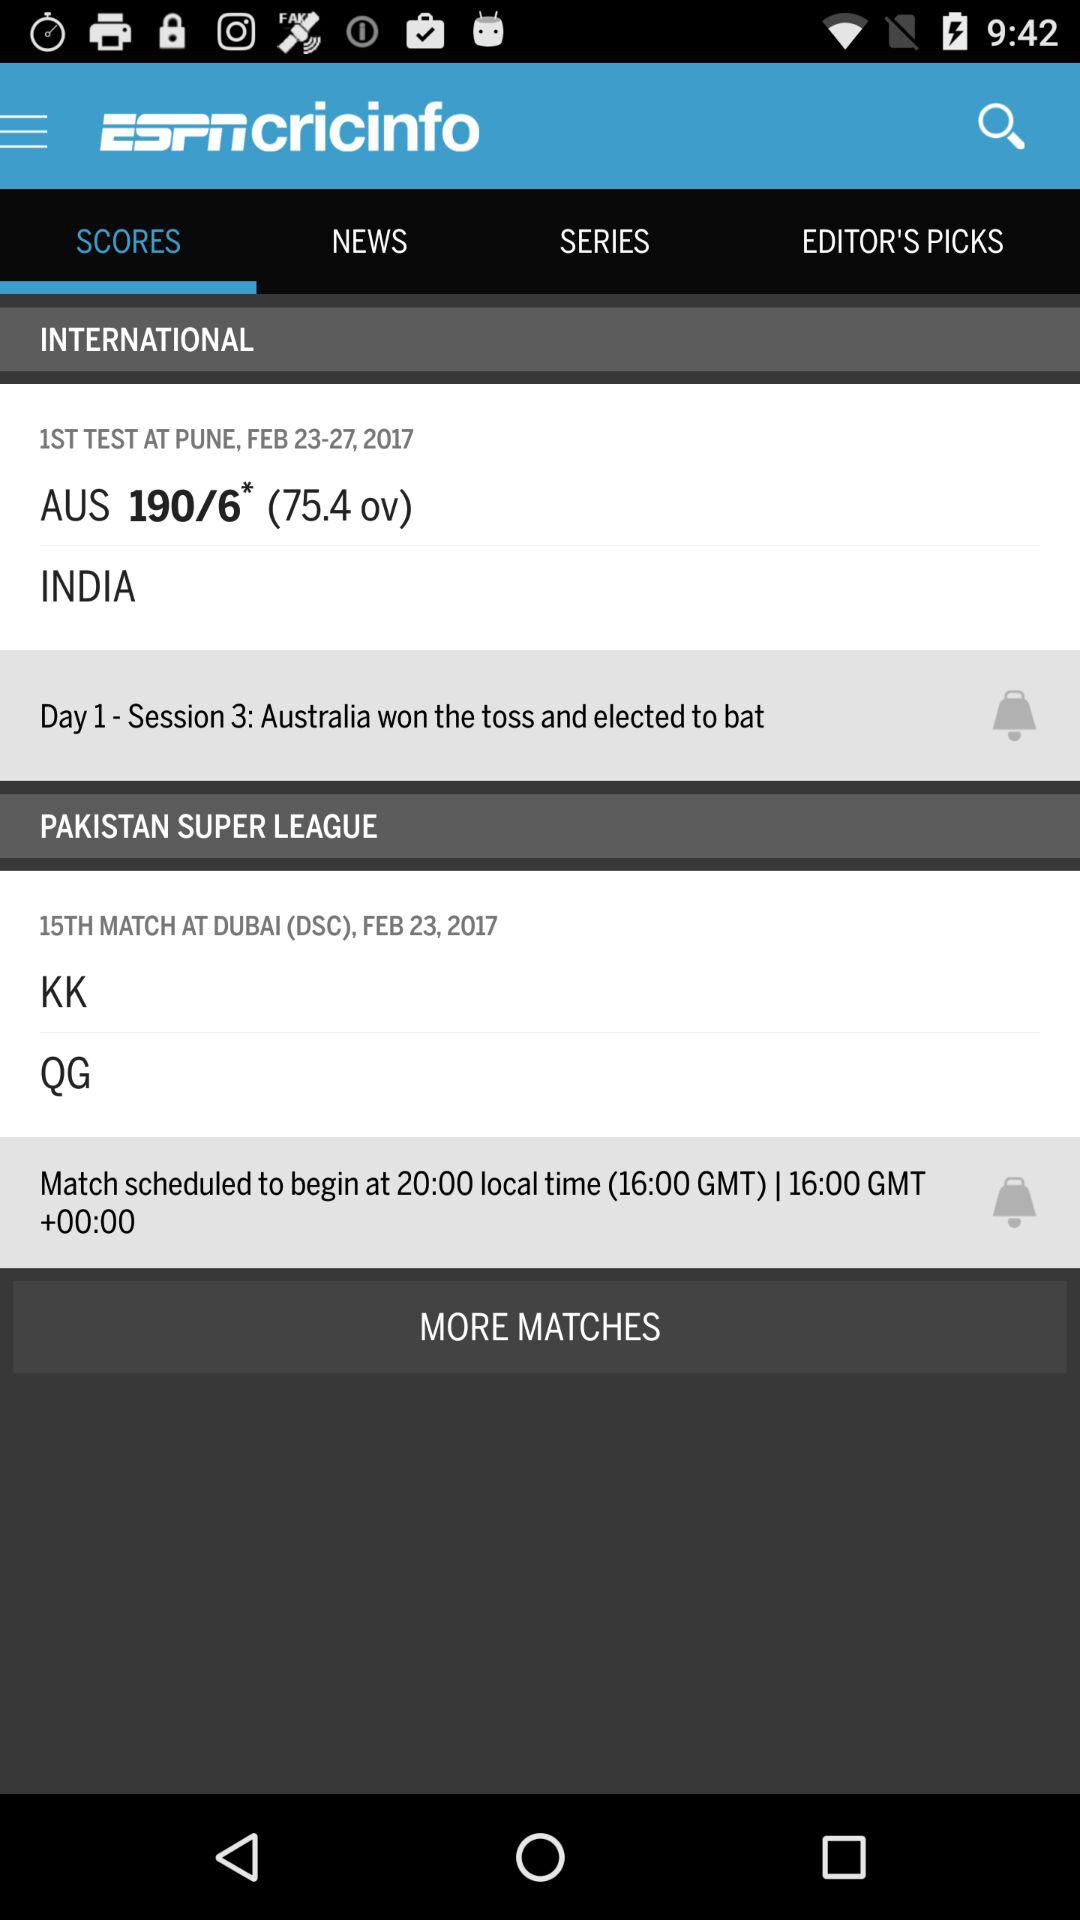How many more matches are in the Pakistan Super League than in the first test?
Answer the question using a single word or phrase. 14 